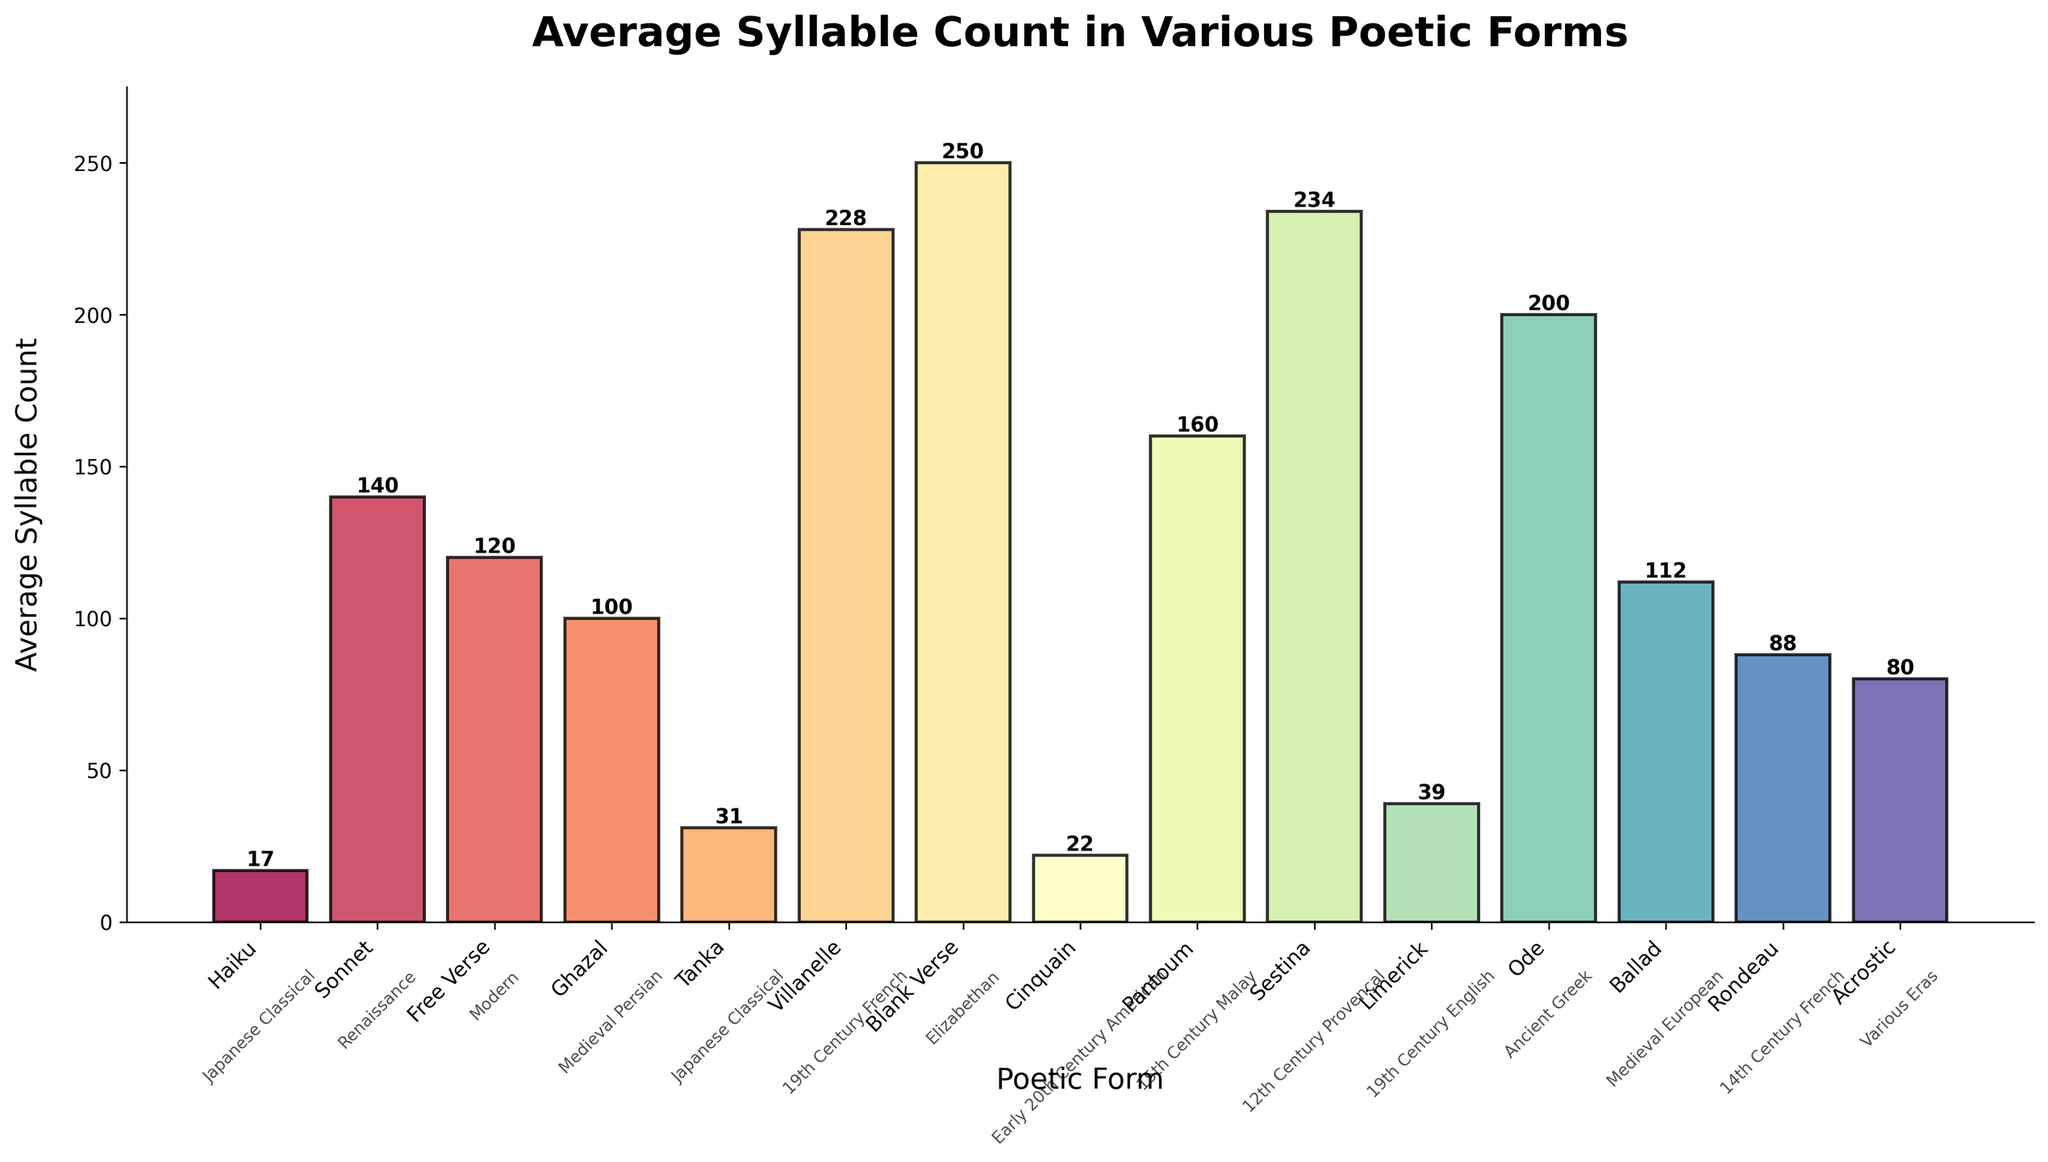Which poetic form has the highest average syllable count? By observing the bar heights in the figure and finding the tallest bar, we see that the form "Blank Verse" has the highest average syllable count.
Answer: Blank Verse Which two poetic forms have the closest average syllable counts, and what are their values? By comparing the bar heights, we can see that "Haiku" and "Cinquain" have the closest syllable counts with 17 and 22 respectively.
Answer: Haiku (17) and Cinquain (22) What is the average syllable count for poetic forms from the Japanese Classical era? There are two poetic forms listed under the Japanese Classical era: Haiku with 17 syllables and Tanka with 31 syllables. Their average is (17 + 31) / 2.
Answer: 24 Are there more poetic forms with average syllable counts above 200 or below 50? From the figure, "Villanelle," "Blank Verse," "Sestina," and "Ode" have counts above 200 (4 forms), while "Haiku" and "Cinquain" have counts below 50 (2 forms). Therefore, more forms exist above 200.
Answer: Above 200 What's the combined average syllable count for all poetic forms of the Medieval era (Persian and European)? The Medieval era includes "Ghazal" with 100 syllables and "Ballad" with 112 syllables. Their combined average is (100 + 112) / 2.
Answer: 106 Which poetic form from the Renaissance era appears on the bar chart, and what is its average syllable count? By examining the periods listed on the visual, we see that "Sonnet" from the Renaissance era has an average syllable count of 140.
Answer: Sonnet (140) If the syllable count of "Pantoum" is doubled, does it exceed the highest syllable count on the chart? The current syllable count for "Pantoum" is 160. Doubling it gives 320, which is greater than the highest syllable count (250 for Blank Verse).
Answer: Yes What is the difference in average syllable count between 'Ode' and 'Rondeau'? The figure shows 'Ode' has 200 syllables, and 'Rondeau' has 88 syllables. The difference is 200 - 88.
Answer: 112 Which poetic forms have average syllable counts between 75 and 150, and what are their values? By examining the syllable counts in the chart, 'Ballad' (112), 'Rondeau' (88), and 'Acrostic' (80) fall within this range.
Answer: Ballad (112), Rondeau (88), Acrostic (80) Count the number of poetic forms with their name located right above the base of the bar. By visually inspecting the chart, you can count each poetic form name located at the base of the bars.
Answer: 15 